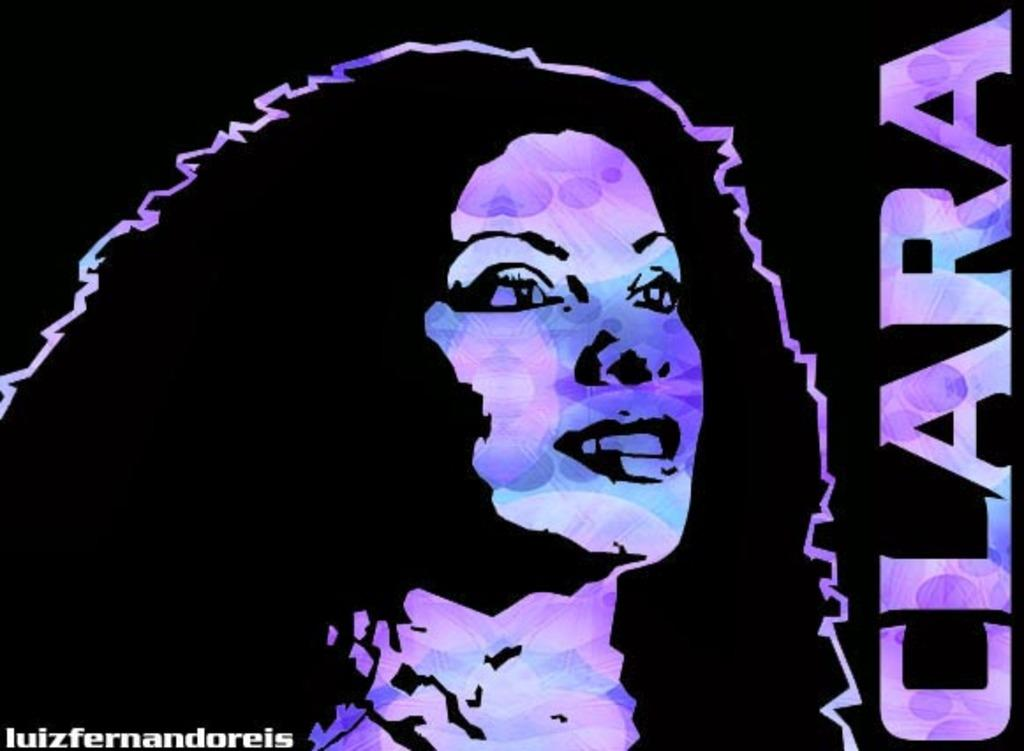What is the main subject of the image? The main subject of the image is an animated painting of a woman. What is the name associated with the painting? The name "CLARA" is present beside the painting. What type of jeans is the woman wearing in the image? The image is a painting, and the woman is not wearing jeans; she is depicted in a painting style. How many men are visible in the image? There are no men visible in the image, as it features an animated painting of a woman. 